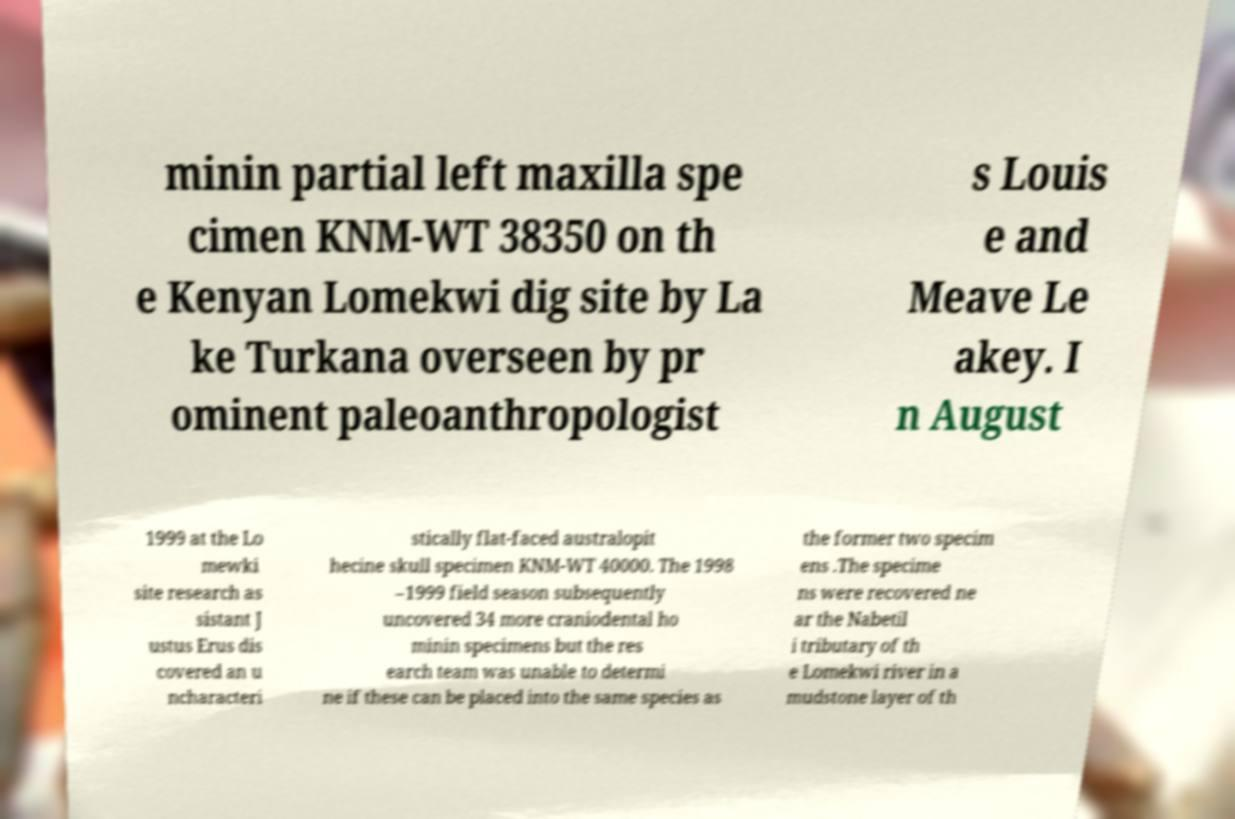Please read and relay the text visible in this image. What does it say? minin partial left maxilla spe cimen KNM-WT 38350 on th e Kenyan Lomekwi dig site by La ke Turkana overseen by pr ominent paleoanthropologist s Louis e and Meave Le akey. I n August 1999 at the Lo mewki site research as sistant J ustus Erus dis covered an u ncharacteri stically flat-faced australopit hecine skull specimen KNM-WT 40000. The 1998 –1999 field season subsequently uncovered 34 more craniodental ho minin specimens but the res earch team was unable to determi ne if these can be placed into the same species as the former two specim ens .The specime ns were recovered ne ar the Nabetil i tributary of th e Lomekwi river in a mudstone layer of th 